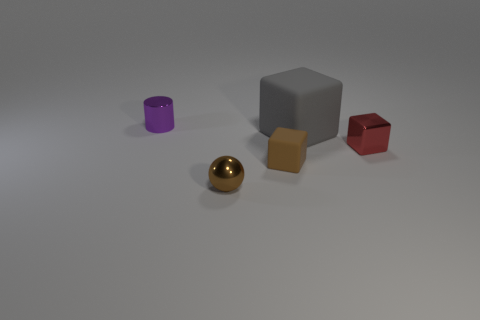Subtract all shiny cubes. How many cubes are left? 2 Add 4 large gray rubber things. How many objects exist? 9 Subtract all red blocks. How many blocks are left? 2 Subtract 0 gray spheres. How many objects are left? 5 Subtract all blocks. How many objects are left? 2 Subtract 1 cylinders. How many cylinders are left? 0 Subtract all blue cubes. Subtract all yellow cylinders. How many cubes are left? 3 Subtract all cyan balls. How many red cubes are left? 1 Subtract all gray blocks. Subtract all large gray cubes. How many objects are left? 3 Add 1 brown metallic balls. How many brown metallic balls are left? 2 